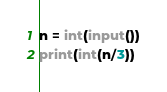Convert code to text. <code><loc_0><loc_0><loc_500><loc_500><_Python_>n = int(input())
print(int(n/3))</code> 